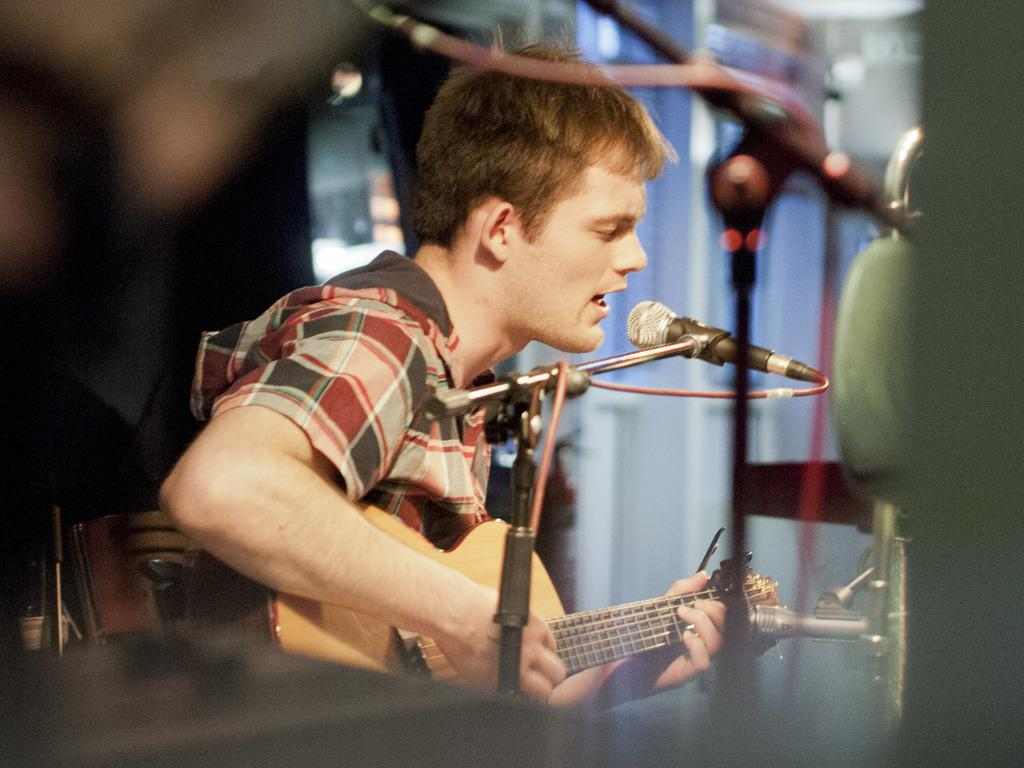What is the man in the image doing? The man is sitting, playing the guitar, and singing. What is the man holding in his hand? The man is holding a guitar in his hand. How is the man's voice being amplified in the image? The man is using a microphone to amplify his voice. What can be seen in the background of the image? There are mic stands and a wall in the background. Are there any pets visible in the image? No, there are no pets visible in the image. Is the man playing the guitar in the snow? No, there is no snow present in the image. 